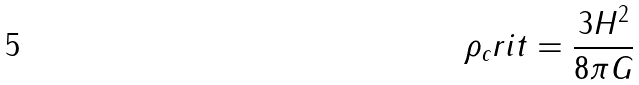<formula> <loc_0><loc_0><loc_500><loc_500>\rho _ { c } r i t = \frac { 3 H ^ { 2 } } { 8 \pi G }</formula> 